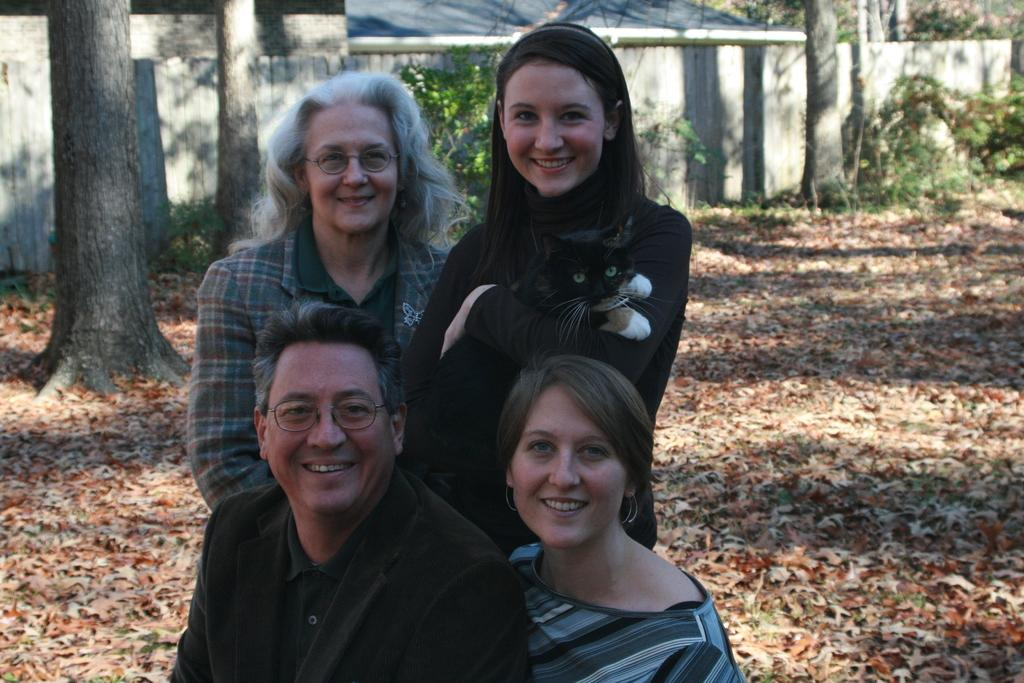How many people are in the image? There are four people in the image. What is one person doing with an animal in the image? One person is holding a cat in the image. What can be seen in the background of the image? There are trees, plants, walls, and dried leaves in the background of the image. What type of zinc is being used by the beginner in the image? There is no zinc or beginner present in the image. 